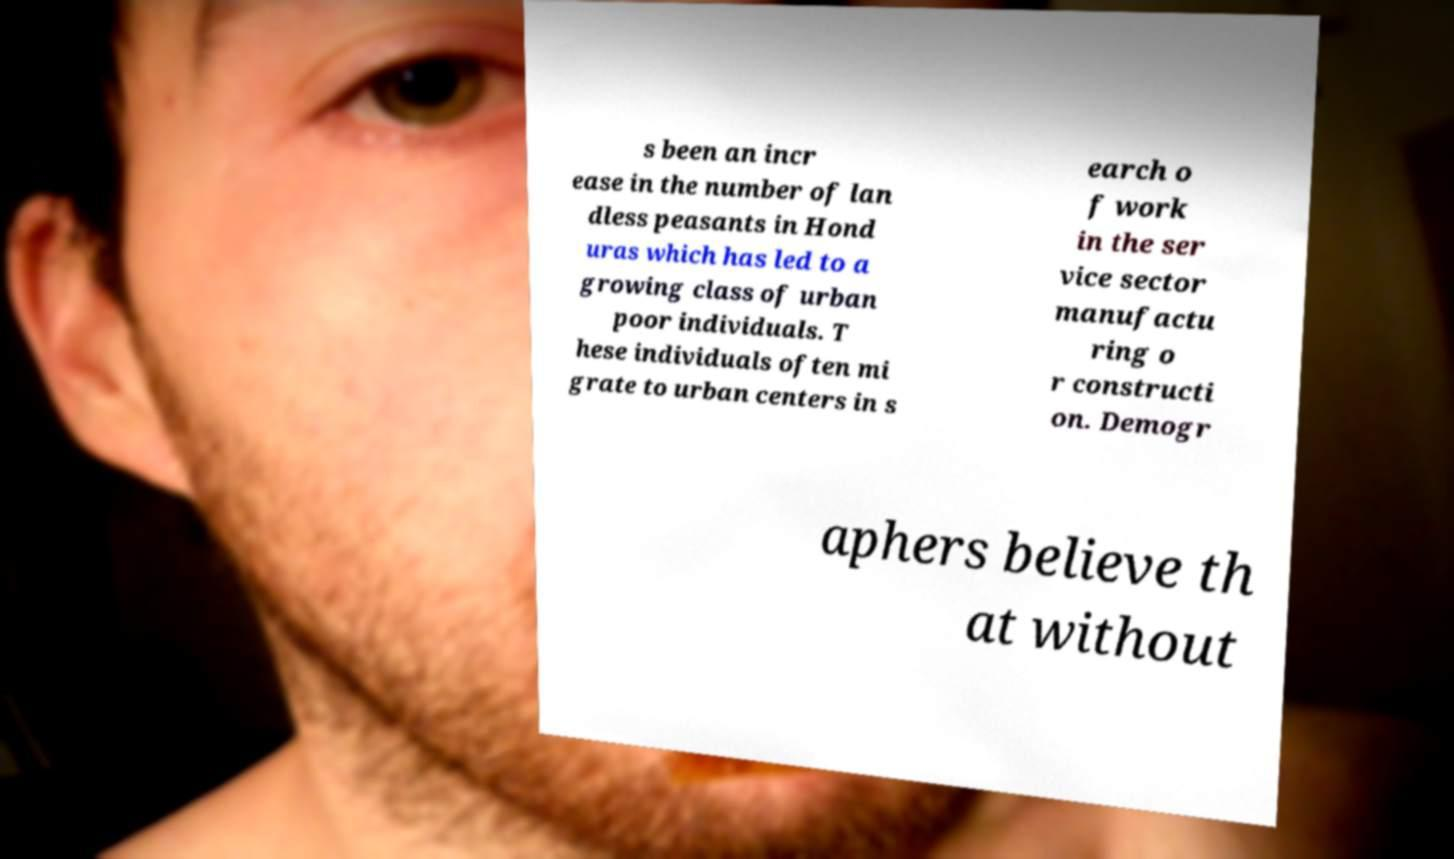Please read and relay the text visible in this image. What does it say? s been an incr ease in the number of lan dless peasants in Hond uras which has led to a growing class of urban poor individuals. T hese individuals often mi grate to urban centers in s earch o f work in the ser vice sector manufactu ring o r constructi on. Demogr aphers believe th at without 